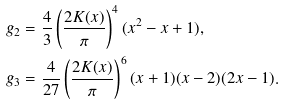Convert formula to latex. <formula><loc_0><loc_0><loc_500><loc_500>& g _ { 2 } = \frac { 4 } { 3 } \left ( \frac { 2 K ( x ) } { \pi } \right ) ^ { 4 } ( x ^ { 2 } - x + 1 ) , \\ & g _ { 3 } = \frac { 4 } { 2 7 } \left ( \frac { 2 K ( x ) } { \pi } \right ) ^ { 6 } ( x + 1 ) ( x - 2 ) ( 2 x - 1 ) .</formula> 